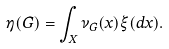Convert formula to latex. <formula><loc_0><loc_0><loc_500><loc_500>\eta ( G ) = \int _ { X } \nu _ { G } ( x ) \xi ( d x ) .</formula> 